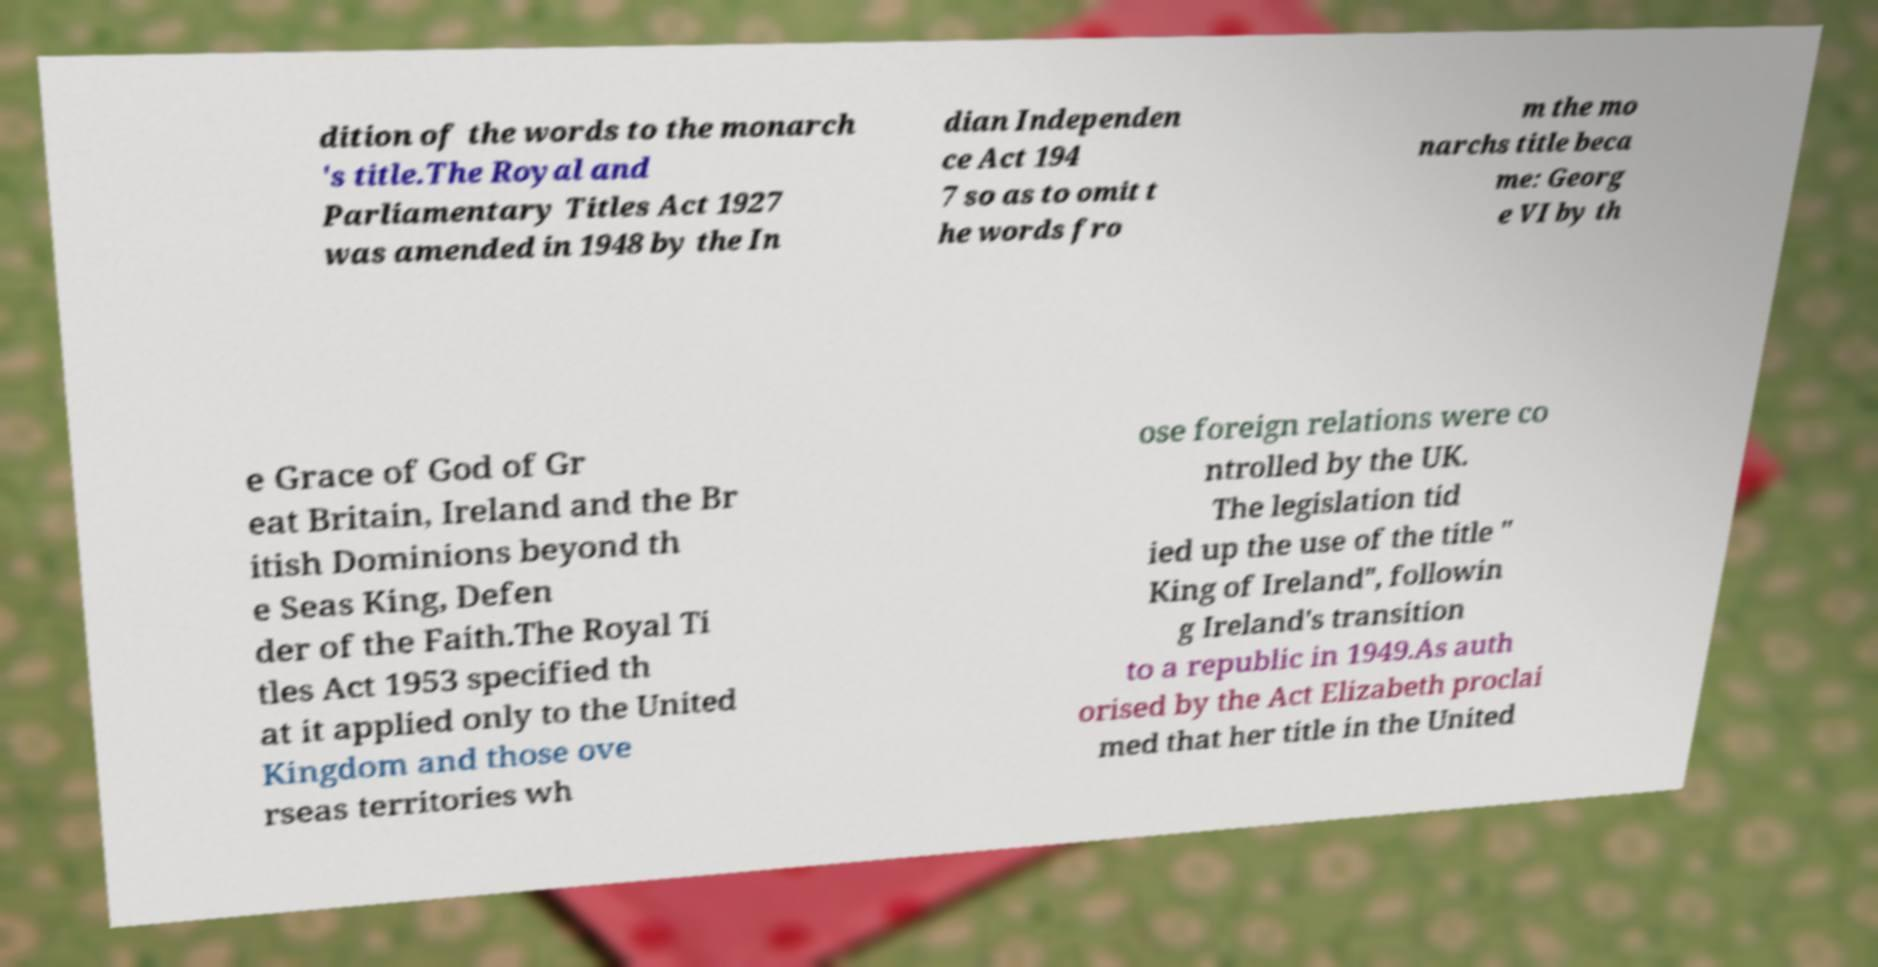For documentation purposes, I need the text within this image transcribed. Could you provide that? dition of the words to the monarch 's title.The Royal and Parliamentary Titles Act 1927 was amended in 1948 by the In dian Independen ce Act 194 7 so as to omit t he words fro m the mo narchs title beca me: Georg e VI by th e Grace of God of Gr eat Britain, Ireland and the Br itish Dominions beyond th e Seas King, Defen der of the Faith.The Royal Ti tles Act 1953 specified th at it applied only to the United Kingdom and those ove rseas territories wh ose foreign relations were co ntrolled by the UK. The legislation tid ied up the use of the title " King of Ireland", followin g Ireland's transition to a republic in 1949.As auth orised by the Act Elizabeth proclai med that her title in the United 